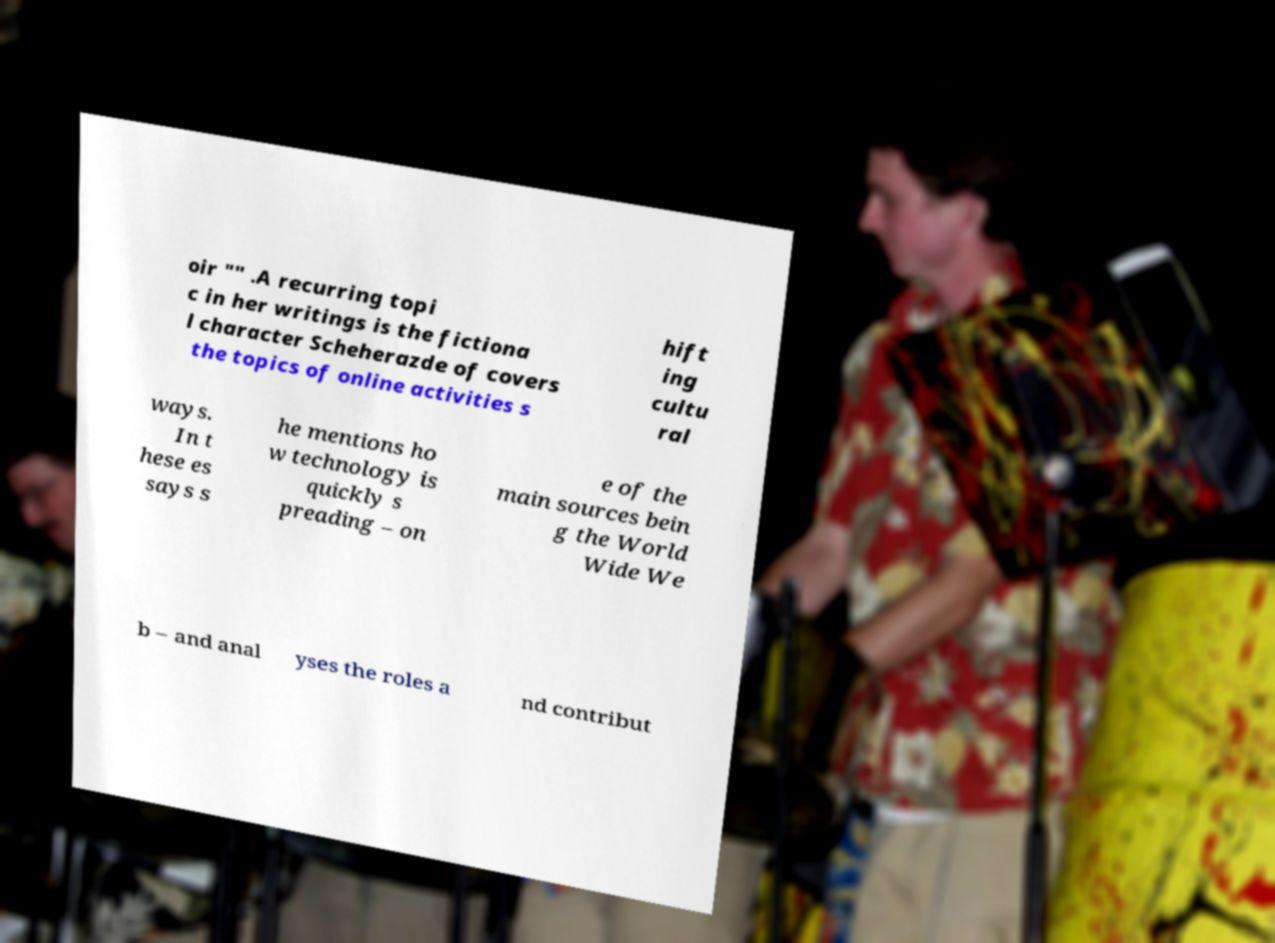Please read and relay the text visible in this image. What does it say? oir "" .A recurring topi c in her writings is the fictiona l character Scheherazde of covers the topics of online activities s hift ing cultu ral ways. In t hese es says s he mentions ho w technology is quickly s preading – on e of the main sources bein g the World Wide We b – and anal yses the roles a nd contribut 